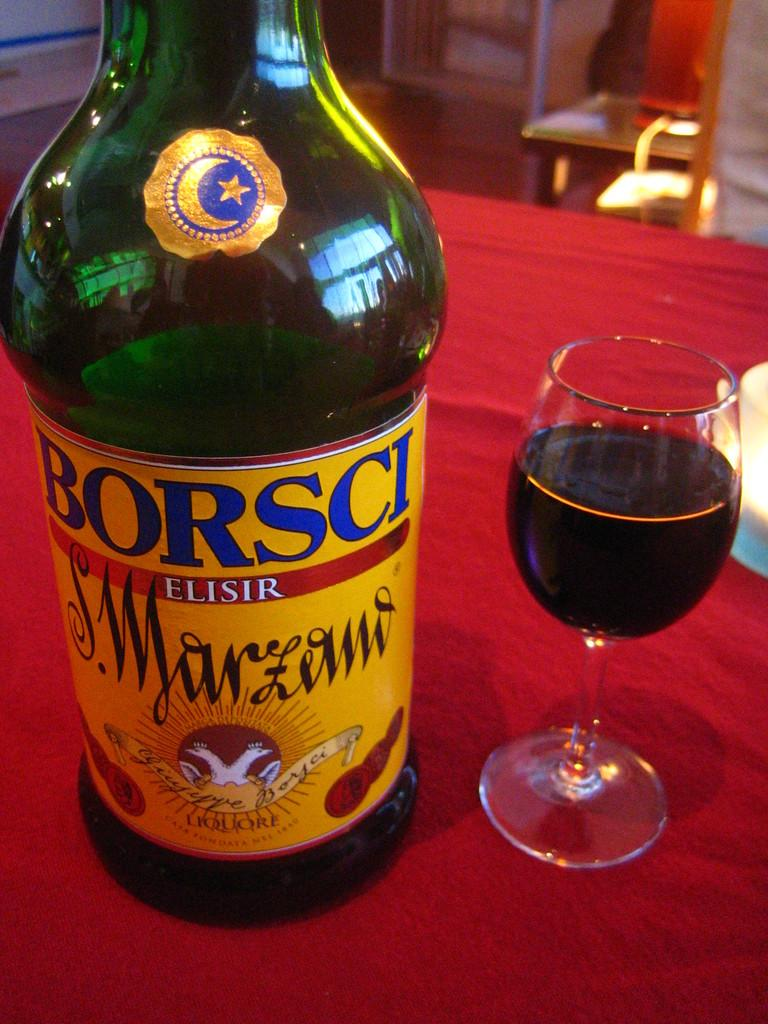Provide a one-sentence caption for the provided image. A bottle of Borsci Elisir is on a table next to a wine glass. 